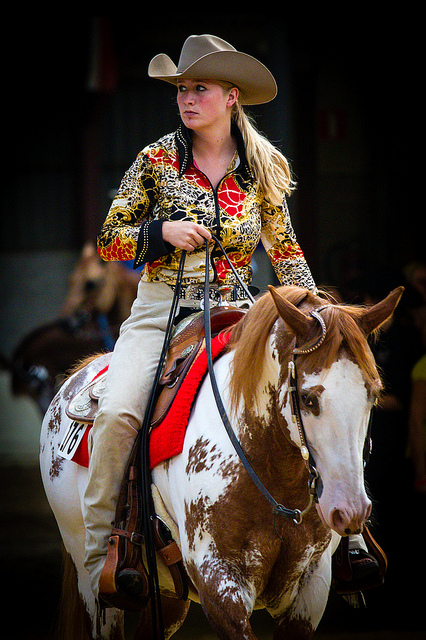Can you tell me more about the event this person might be participating in? Based on the attire and saddle, it seems the person is participating in a Western riding competition, possibly at a rodeo or horse show. These events often include activities such as barrel racing, pole bending, or reining, where riders exhibit their riding abilities and their horses' agility and speed. 